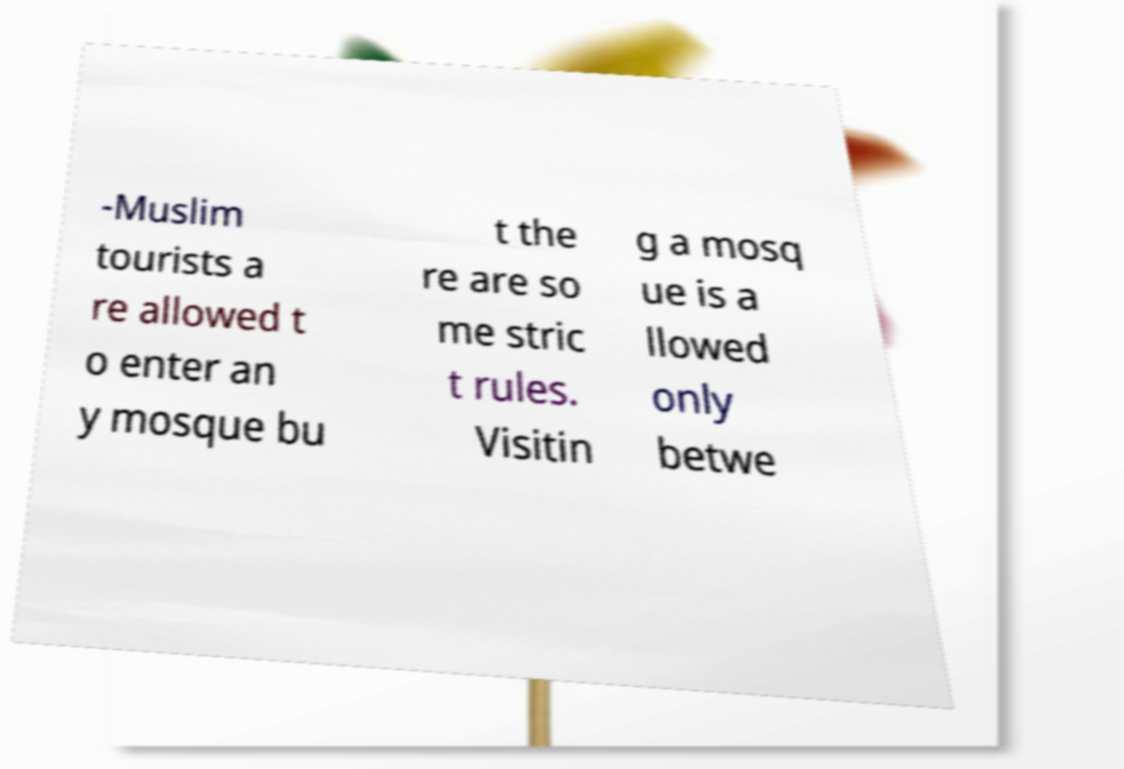Please read and relay the text visible in this image. What does it say? -Muslim tourists a re allowed t o enter an y mosque bu t the re are so me stric t rules. Visitin g a mosq ue is a llowed only betwe 